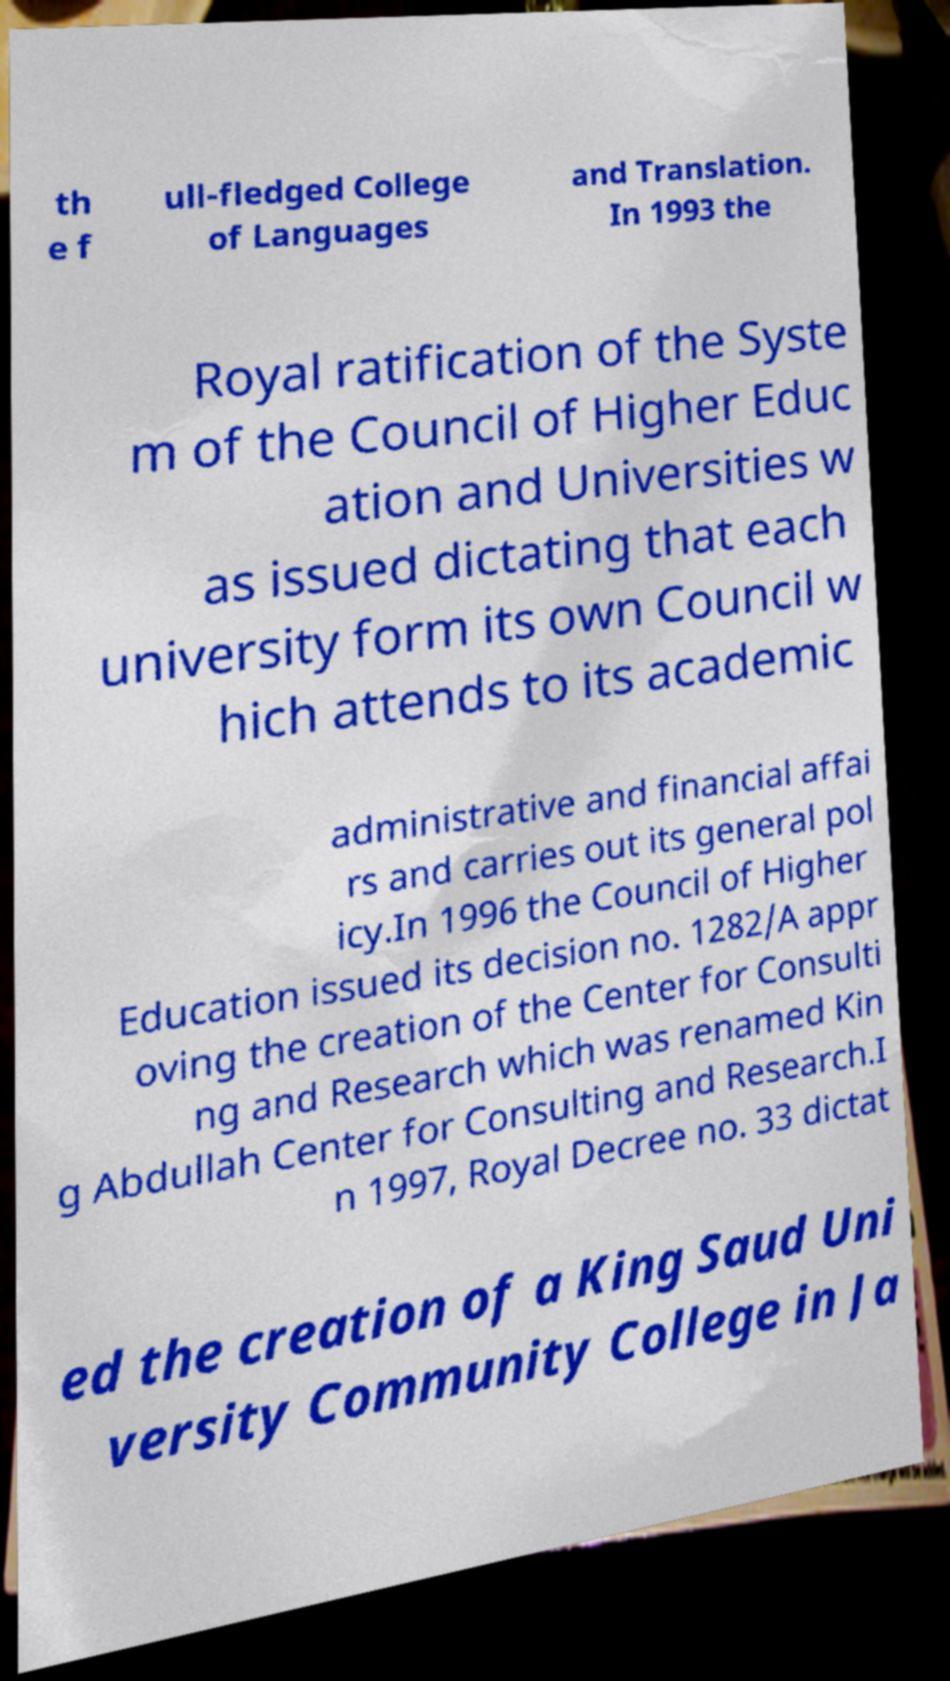Please identify and transcribe the text found in this image. th e f ull-fledged College of Languages and Translation. In 1993 the Royal ratification of the Syste m of the Council of Higher Educ ation and Universities w as issued dictating that each university form its own Council w hich attends to its academic administrative and financial affai rs and carries out its general pol icy.In 1996 the Council of Higher Education issued its decision no. 1282/A appr oving the creation of the Center for Consulti ng and Research which was renamed Kin g Abdullah Center for Consulting and Research.I n 1997, Royal Decree no. 33 dictat ed the creation of a King Saud Uni versity Community College in Ja 